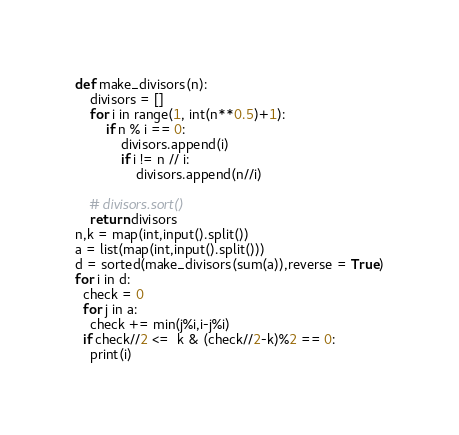Convert code to text. <code><loc_0><loc_0><loc_500><loc_500><_Python_>def make_divisors(n):
    divisors = []
    for i in range(1, int(n**0.5)+1):
        if n % i == 0:
            divisors.append(i)
            if i != n // i:
                divisors.append(n//i)

    # divisors.sort()
    return divisors
n,k = map(int,input().split())
a = list(map(int,input().split()))
d = sorted(make_divisors(sum(a)),reverse = True)
for i in d:
  check = 0
  for j in a:
    check += min(j%i,i-j%i)
  if check//2 <=  k & (check//2-k)%2 == 0:
    print(i)
</code> 